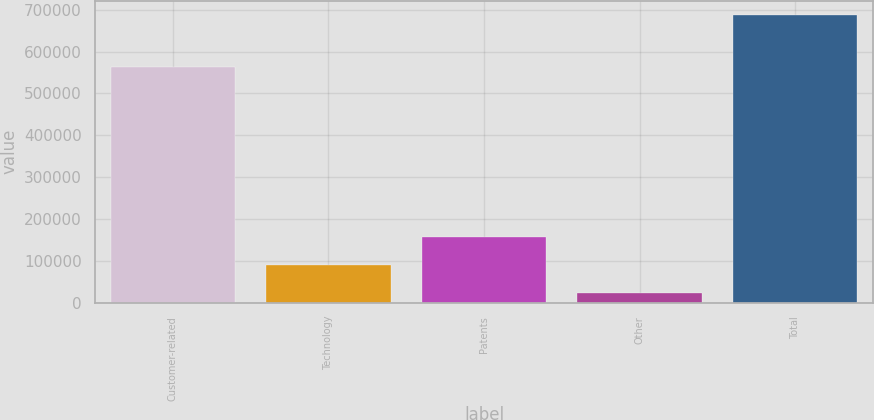Convert chart to OTSL. <chart><loc_0><loc_0><loc_500><loc_500><bar_chart><fcel>Customer-related<fcel>Technology<fcel>Patents<fcel>Other<fcel>Total<nl><fcel>562716<fcel>90059<fcel>156398<fcel>23720<fcel>687110<nl></chart> 